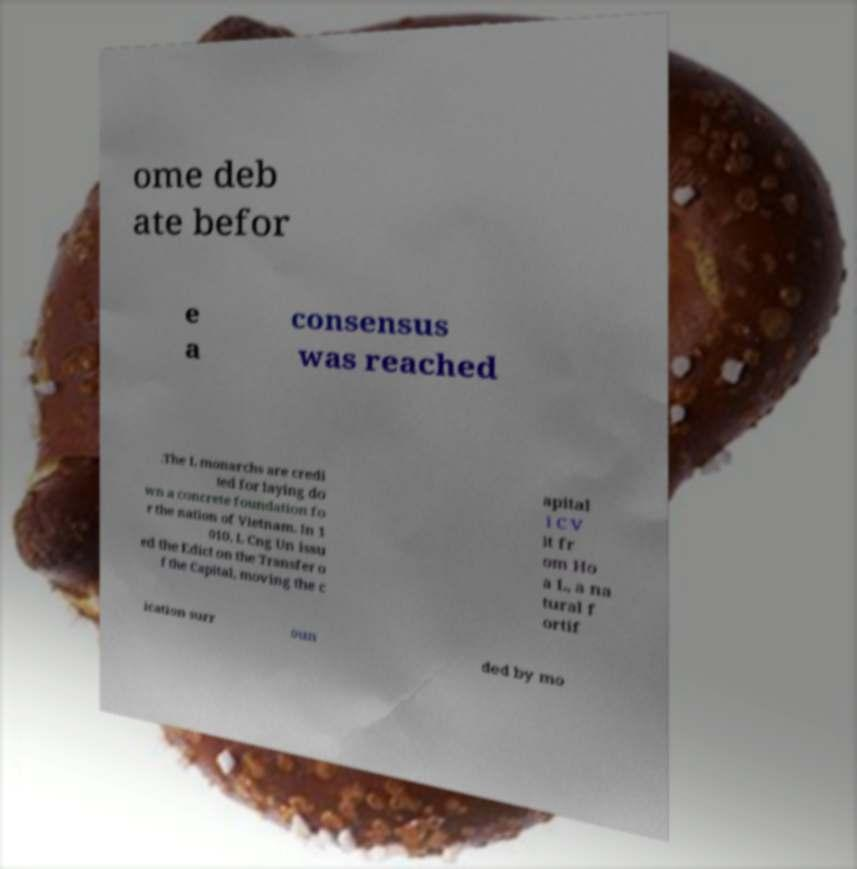Can you read and provide the text displayed in the image?This photo seems to have some interesting text. Can you extract and type it out for me? ome deb ate befor e a consensus was reached .The L monarchs are credi ted for laying do wn a concrete foundation fo r the nation of Vietnam. In 1 010, L Cng Un issu ed the Edict on the Transfer o f the Capital, moving the c apital i C V it fr om Ho a L, a na tural f ortif ication surr oun ded by mo 